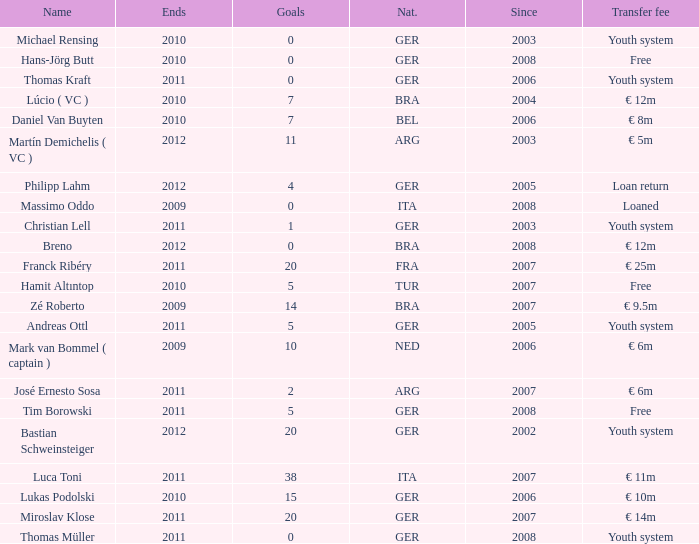What is the lowest year in since that had a transfer fee of € 14m and ended after 2011? None. 